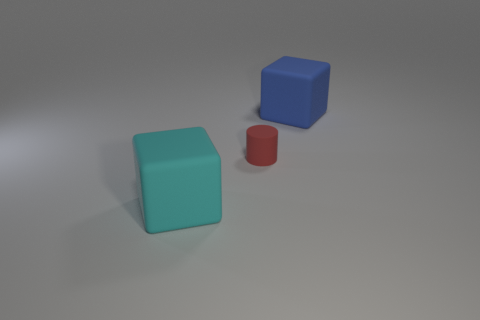What is the size of the other rubber thing that is the same shape as the large blue thing?
Your response must be concise. Large. Are the large blue object and the large block in front of the small red matte cylinder made of the same material?
Give a very brief answer. Yes. What number of things are large cyan rubber objects or large objects?
Give a very brief answer. 2. There is a matte cube in front of the small red cylinder; is it the same size as the rubber cube that is right of the tiny thing?
Provide a succinct answer. Yes. What number of cubes are either cyan things or blue objects?
Give a very brief answer. 2. Is there a small cyan metallic sphere?
Your answer should be very brief. No. Are there any other things that are the same shape as the big cyan matte thing?
Keep it short and to the point. Yes. How many things are big things in front of the tiny matte cylinder or large blue matte things?
Your response must be concise. 2. There is a big matte block in front of the large matte cube to the right of the small cylinder; what number of large objects are on the left side of it?
Offer a very short reply. 0. Are there any other things that have the same size as the red rubber object?
Offer a very short reply. No. 